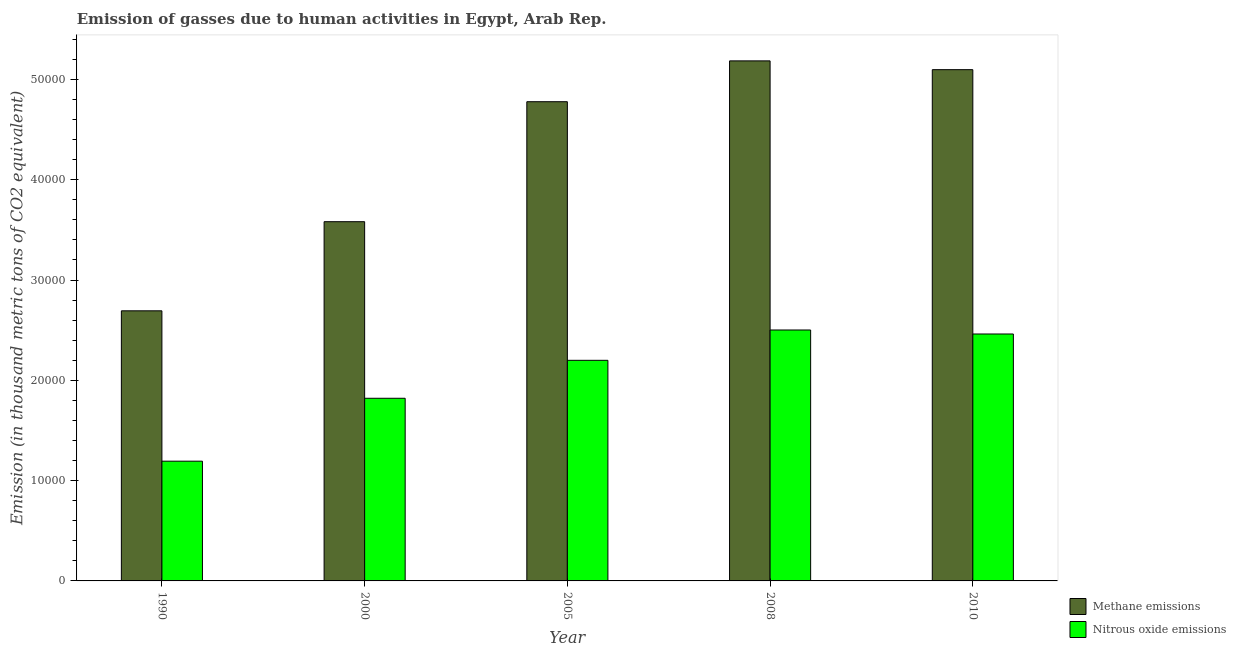How many different coloured bars are there?
Offer a very short reply. 2. How many groups of bars are there?
Your response must be concise. 5. Are the number of bars on each tick of the X-axis equal?
Offer a very short reply. Yes. How many bars are there on the 1st tick from the left?
Keep it short and to the point. 2. How many bars are there on the 1st tick from the right?
Your response must be concise. 2. In how many cases, is the number of bars for a given year not equal to the number of legend labels?
Provide a short and direct response. 0. What is the amount of nitrous oxide emissions in 1990?
Your response must be concise. 1.19e+04. Across all years, what is the maximum amount of nitrous oxide emissions?
Provide a short and direct response. 2.50e+04. Across all years, what is the minimum amount of nitrous oxide emissions?
Give a very brief answer. 1.19e+04. What is the total amount of methane emissions in the graph?
Offer a very short reply. 2.13e+05. What is the difference between the amount of methane emissions in 1990 and that in 2000?
Provide a short and direct response. -8884.8. What is the difference between the amount of nitrous oxide emissions in 1990 and the amount of methane emissions in 2008?
Your response must be concise. -1.31e+04. What is the average amount of methane emissions per year?
Give a very brief answer. 4.27e+04. In the year 2010, what is the difference between the amount of nitrous oxide emissions and amount of methane emissions?
Your response must be concise. 0. What is the ratio of the amount of nitrous oxide emissions in 2005 to that in 2010?
Your response must be concise. 0.89. Is the amount of methane emissions in 2000 less than that in 2005?
Keep it short and to the point. Yes. What is the difference between the highest and the second highest amount of methane emissions?
Provide a succinct answer. 876.7. What is the difference between the highest and the lowest amount of nitrous oxide emissions?
Keep it short and to the point. 1.31e+04. In how many years, is the amount of methane emissions greater than the average amount of methane emissions taken over all years?
Offer a terse response. 3. Is the sum of the amount of methane emissions in 2008 and 2010 greater than the maximum amount of nitrous oxide emissions across all years?
Your response must be concise. Yes. What does the 2nd bar from the left in 2000 represents?
Make the answer very short. Nitrous oxide emissions. What does the 1st bar from the right in 2008 represents?
Provide a short and direct response. Nitrous oxide emissions. Are the values on the major ticks of Y-axis written in scientific E-notation?
Your answer should be very brief. No. Does the graph contain grids?
Give a very brief answer. No. Where does the legend appear in the graph?
Your answer should be compact. Bottom right. How many legend labels are there?
Your answer should be very brief. 2. What is the title of the graph?
Your answer should be very brief. Emission of gasses due to human activities in Egypt, Arab Rep. Does "National Tourists" appear as one of the legend labels in the graph?
Keep it short and to the point. No. What is the label or title of the Y-axis?
Provide a succinct answer. Emission (in thousand metric tons of CO2 equivalent). What is the Emission (in thousand metric tons of CO2 equivalent) of Methane emissions in 1990?
Ensure brevity in your answer.  2.69e+04. What is the Emission (in thousand metric tons of CO2 equivalent) in Nitrous oxide emissions in 1990?
Provide a succinct answer. 1.19e+04. What is the Emission (in thousand metric tons of CO2 equivalent) of Methane emissions in 2000?
Your answer should be compact. 3.58e+04. What is the Emission (in thousand metric tons of CO2 equivalent) in Nitrous oxide emissions in 2000?
Provide a short and direct response. 1.82e+04. What is the Emission (in thousand metric tons of CO2 equivalent) in Methane emissions in 2005?
Make the answer very short. 4.78e+04. What is the Emission (in thousand metric tons of CO2 equivalent) of Nitrous oxide emissions in 2005?
Offer a very short reply. 2.20e+04. What is the Emission (in thousand metric tons of CO2 equivalent) in Methane emissions in 2008?
Ensure brevity in your answer.  5.18e+04. What is the Emission (in thousand metric tons of CO2 equivalent) of Nitrous oxide emissions in 2008?
Your answer should be compact. 2.50e+04. What is the Emission (in thousand metric tons of CO2 equivalent) in Methane emissions in 2010?
Make the answer very short. 5.10e+04. What is the Emission (in thousand metric tons of CO2 equivalent) in Nitrous oxide emissions in 2010?
Provide a succinct answer. 2.46e+04. Across all years, what is the maximum Emission (in thousand metric tons of CO2 equivalent) of Methane emissions?
Your answer should be compact. 5.18e+04. Across all years, what is the maximum Emission (in thousand metric tons of CO2 equivalent) in Nitrous oxide emissions?
Ensure brevity in your answer.  2.50e+04. Across all years, what is the minimum Emission (in thousand metric tons of CO2 equivalent) of Methane emissions?
Make the answer very short. 2.69e+04. Across all years, what is the minimum Emission (in thousand metric tons of CO2 equivalent) of Nitrous oxide emissions?
Keep it short and to the point. 1.19e+04. What is the total Emission (in thousand metric tons of CO2 equivalent) in Methane emissions in the graph?
Your answer should be compact. 2.13e+05. What is the total Emission (in thousand metric tons of CO2 equivalent) in Nitrous oxide emissions in the graph?
Your answer should be very brief. 1.02e+05. What is the difference between the Emission (in thousand metric tons of CO2 equivalent) in Methane emissions in 1990 and that in 2000?
Provide a succinct answer. -8884.8. What is the difference between the Emission (in thousand metric tons of CO2 equivalent) of Nitrous oxide emissions in 1990 and that in 2000?
Make the answer very short. -6272.2. What is the difference between the Emission (in thousand metric tons of CO2 equivalent) of Methane emissions in 1990 and that in 2005?
Offer a very short reply. -2.08e+04. What is the difference between the Emission (in thousand metric tons of CO2 equivalent) in Nitrous oxide emissions in 1990 and that in 2005?
Your answer should be very brief. -1.01e+04. What is the difference between the Emission (in thousand metric tons of CO2 equivalent) in Methane emissions in 1990 and that in 2008?
Your response must be concise. -2.49e+04. What is the difference between the Emission (in thousand metric tons of CO2 equivalent) of Nitrous oxide emissions in 1990 and that in 2008?
Your answer should be very brief. -1.31e+04. What is the difference between the Emission (in thousand metric tons of CO2 equivalent) in Methane emissions in 1990 and that in 2010?
Offer a very short reply. -2.40e+04. What is the difference between the Emission (in thousand metric tons of CO2 equivalent) in Nitrous oxide emissions in 1990 and that in 2010?
Your answer should be very brief. -1.27e+04. What is the difference between the Emission (in thousand metric tons of CO2 equivalent) in Methane emissions in 2000 and that in 2005?
Provide a succinct answer. -1.20e+04. What is the difference between the Emission (in thousand metric tons of CO2 equivalent) of Nitrous oxide emissions in 2000 and that in 2005?
Your answer should be very brief. -3783.9. What is the difference between the Emission (in thousand metric tons of CO2 equivalent) in Methane emissions in 2000 and that in 2008?
Provide a succinct answer. -1.60e+04. What is the difference between the Emission (in thousand metric tons of CO2 equivalent) in Nitrous oxide emissions in 2000 and that in 2008?
Your answer should be compact. -6806.9. What is the difference between the Emission (in thousand metric tons of CO2 equivalent) in Methane emissions in 2000 and that in 2010?
Your answer should be very brief. -1.52e+04. What is the difference between the Emission (in thousand metric tons of CO2 equivalent) of Nitrous oxide emissions in 2000 and that in 2010?
Your answer should be very brief. -6408.6. What is the difference between the Emission (in thousand metric tons of CO2 equivalent) in Methane emissions in 2005 and that in 2008?
Offer a very short reply. -4070.7. What is the difference between the Emission (in thousand metric tons of CO2 equivalent) of Nitrous oxide emissions in 2005 and that in 2008?
Provide a short and direct response. -3023. What is the difference between the Emission (in thousand metric tons of CO2 equivalent) of Methane emissions in 2005 and that in 2010?
Provide a short and direct response. -3194. What is the difference between the Emission (in thousand metric tons of CO2 equivalent) in Nitrous oxide emissions in 2005 and that in 2010?
Provide a short and direct response. -2624.7. What is the difference between the Emission (in thousand metric tons of CO2 equivalent) of Methane emissions in 2008 and that in 2010?
Your answer should be compact. 876.7. What is the difference between the Emission (in thousand metric tons of CO2 equivalent) of Nitrous oxide emissions in 2008 and that in 2010?
Provide a succinct answer. 398.3. What is the difference between the Emission (in thousand metric tons of CO2 equivalent) of Methane emissions in 1990 and the Emission (in thousand metric tons of CO2 equivalent) of Nitrous oxide emissions in 2000?
Offer a very short reply. 8718.8. What is the difference between the Emission (in thousand metric tons of CO2 equivalent) of Methane emissions in 1990 and the Emission (in thousand metric tons of CO2 equivalent) of Nitrous oxide emissions in 2005?
Keep it short and to the point. 4934.9. What is the difference between the Emission (in thousand metric tons of CO2 equivalent) in Methane emissions in 1990 and the Emission (in thousand metric tons of CO2 equivalent) in Nitrous oxide emissions in 2008?
Make the answer very short. 1911.9. What is the difference between the Emission (in thousand metric tons of CO2 equivalent) of Methane emissions in 1990 and the Emission (in thousand metric tons of CO2 equivalent) of Nitrous oxide emissions in 2010?
Make the answer very short. 2310.2. What is the difference between the Emission (in thousand metric tons of CO2 equivalent) of Methane emissions in 2000 and the Emission (in thousand metric tons of CO2 equivalent) of Nitrous oxide emissions in 2005?
Provide a succinct answer. 1.38e+04. What is the difference between the Emission (in thousand metric tons of CO2 equivalent) of Methane emissions in 2000 and the Emission (in thousand metric tons of CO2 equivalent) of Nitrous oxide emissions in 2008?
Your answer should be compact. 1.08e+04. What is the difference between the Emission (in thousand metric tons of CO2 equivalent) in Methane emissions in 2000 and the Emission (in thousand metric tons of CO2 equivalent) in Nitrous oxide emissions in 2010?
Keep it short and to the point. 1.12e+04. What is the difference between the Emission (in thousand metric tons of CO2 equivalent) of Methane emissions in 2005 and the Emission (in thousand metric tons of CO2 equivalent) of Nitrous oxide emissions in 2008?
Keep it short and to the point. 2.28e+04. What is the difference between the Emission (in thousand metric tons of CO2 equivalent) in Methane emissions in 2005 and the Emission (in thousand metric tons of CO2 equivalent) in Nitrous oxide emissions in 2010?
Your answer should be very brief. 2.32e+04. What is the difference between the Emission (in thousand metric tons of CO2 equivalent) of Methane emissions in 2008 and the Emission (in thousand metric tons of CO2 equivalent) of Nitrous oxide emissions in 2010?
Your answer should be very brief. 2.72e+04. What is the average Emission (in thousand metric tons of CO2 equivalent) in Methane emissions per year?
Make the answer very short. 4.27e+04. What is the average Emission (in thousand metric tons of CO2 equivalent) in Nitrous oxide emissions per year?
Keep it short and to the point. 2.04e+04. In the year 1990, what is the difference between the Emission (in thousand metric tons of CO2 equivalent) in Methane emissions and Emission (in thousand metric tons of CO2 equivalent) in Nitrous oxide emissions?
Offer a terse response. 1.50e+04. In the year 2000, what is the difference between the Emission (in thousand metric tons of CO2 equivalent) in Methane emissions and Emission (in thousand metric tons of CO2 equivalent) in Nitrous oxide emissions?
Provide a short and direct response. 1.76e+04. In the year 2005, what is the difference between the Emission (in thousand metric tons of CO2 equivalent) of Methane emissions and Emission (in thousand metric tons of CO2 equivalent) of Nitrous oxide emissions?
Your answer should be very brief. 2.58e+04. In the year 2008, what is the difference between the Emission (in thousand metric tons of CO2 equivalent) of Methane emissions and Emission (in thousand metric tons of CO2 equivalent) of Nitrous oxide emissions?
Make the answer very short. 2.68e+04. In the year 2010, what is the difference between the Emission (in thousand metric tons of CO2 equivalent) of Methane emissions and Emission (in thousand metric tons of CO2 equivalent) of Nitrous oxide emissions?
Your answer should be very brief. 2.64e+04. What is the ratio of the Emission (in thousand metric tons of CO2 equivalent) of Methane emissions in 1990 to that in 2000?
Keep it short and to the point. 0.75. What is the ratio of the Emission (in thousand metric tons of CO2 equivalent) of Nitrous oxide emissions in 1990 to that in 2000?
Offer a terse response. 0.66. What is the ratio of the Emission (in thousand metric tons of CO2 equivalent) in Methane emissions in 1990 to that in 2005?
Your answer should be very brief. 0.56. What is the ratio of the Emission (in thousand metric tons of CO2 equivalent) of Nitrous oxide emissions in 1990 to that in 2005?
Your answer should be very brief. 0.54. What is the ratio of the Emission (in thousand metric tons of CO2 equivalent) of Methane emissions in 1990 to that in 2008?
Keep it short and to the point. 0.52. What is the ratio of the Emission (in thousand metric tons of CO2 equivalent) in Nitrous oxide emissions in 1990 to that in 2008?
Provide a succinct answer. 0.48. What is the ratio of the Emission (in thousand metric tons of CO2 equivalent) of Methane emissions in 1990 to that in 2010?
Make the answer very short. 0.53. What is the ratio of the Emission (in thousand metric tons of CO2 equivalent) in Nitrous oxide emissions in 1990 to that in 2010?
Your answer should be very brief. 0.48. What is the ratio of the Emission (in thousand metric tons of CO2 equivalent) in Methane emissions in 2000 to that in 2005?
Offer a terse response. 0.75. What is the ratio of the Emission (in thousand metric tons of CO2 equivalent) of Nitrous oxide emissions in 2000 to that in 2005?
Give a very brief answer. 0.83. What is the ratio of the Emission (in thousand metric tons of CO2 equivalent) of Methane emissions in 2000 to that in 2008?
Your answer should be very brief. 0.69. What is the ratio of the Emission (in thousand metric tons of CO2 equivalent) of Nitrous oxide emissions in 2000 to that in 2008?
Your answer should be very brief. 0.73. What is the ratio of the Emission (in thousand metric tons of CO2 equivalent) in Methane emissions in 2000 to that in 2010?
Your answer should be compact. 0.7. What is the ratio of the Emission (in thousand metric tons of CO2 equivalent) in Nitrous oxide emissions in 2000 to that in 2010?
Your answer should be very brief. 0.74. What is the ratio of the Emission (in thousand metric tons of CO2 equivalent) of Methane emissions in 2005 to that in 2008?
Offer a very short reply. 0.92. What is the ratio of the Emission (in thousand metric tons of CO2 equivalent) in Nitrous oxide emissions in 2005 to that in 2008?
Your answer should be very brief. 0.88. What is the ratio of the Emission (in thousand metric tons of CO2 equivalent) of Methane emissions in 2005 to that in 2010?
Your response must be concise. 0.94. What is the ratio of the Emission (in thousand metric tons of CO2 equivalent) of Nitrous oxide emissions in 2005 to that in 2010?
Your answer should be compact. 0.89. What is the ratio of the Emission (in thousand metric tons of CO2 equivalent) in Methane emissions in 2008 to that in 2010?
Ensure brevity in your answer.  1.02. What is the ratio of the Emission (in thousand metric tons of CO2 equivalent) in Nitrous oxide emissions in 2008 to that in 2010?
Your answer should be compact. 1.02. What is the difference between the highest and the second highest Emission (in thousand metric tons of CO2 equivalent) of Methane emissions?
Ensure brevity in your answer.  876.7. What is the difference between the highest and the second highest Emission (in thousand metric tons of CO2 equivalent) in Nitrous oxide emissions?
Your answer should be very brief. 398.3. What is the difference between the highest and the lowest Emission (in thousand metric tons of CO2 equivalent) in Methane emissions?
Make the answer very short. 2.49e+04. What is the difference between the highest and the lowest Emission (in thousand metric tons of CO2 equivalent) of Nitrous oxide emissions?
Make the answer very short. 1.31e+04. 